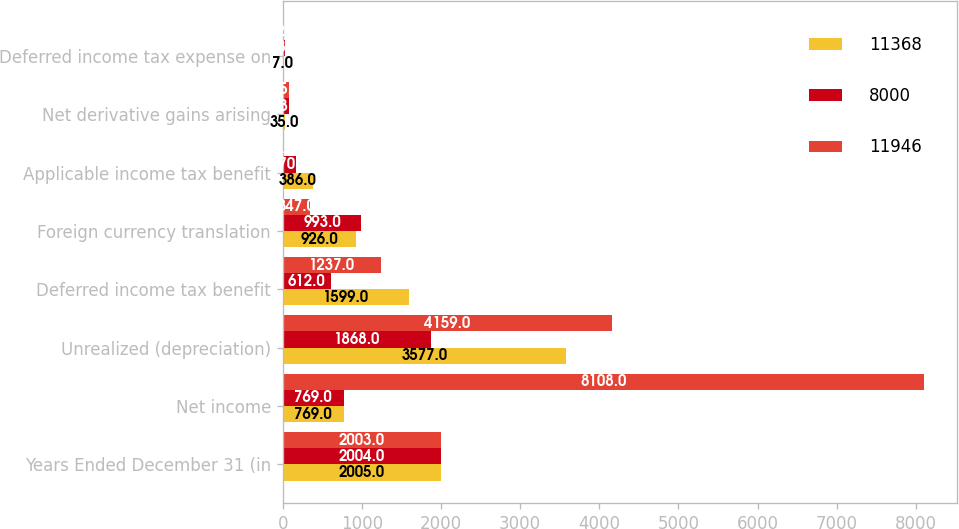<chart> <loc_0><loc_0><loc_500><loc_500><stacked_bar_chart><ecel><fcel>Years Ended December 31 (in<fcel>Net income<fcel>Unrealized (depreciation)<fcel>Deferred income tax benefit<fcel>Foreign currency translation<fcel>Applicable income tax benefit<fcel>Net derivative gains arising<fcel>Deferred income tax expense on<nl><fcel>11368<fcel>2005<fcel>769<fcel>3577<fcel>1599<fcel>926<fcel>386<fcel>35<fcel>7<nl><fcel>8000<fcel>2004<fcel>769<fcel>1868<fcel>612<fcel>993<fcel>170<fcel>83<fcel>33<nl><fcel>11946<fcel>2003<fcel>8108<fcel>4159<fcel>1237<fcel>347<fcel>4<fcel>75<fcel>22<nl></chart> 